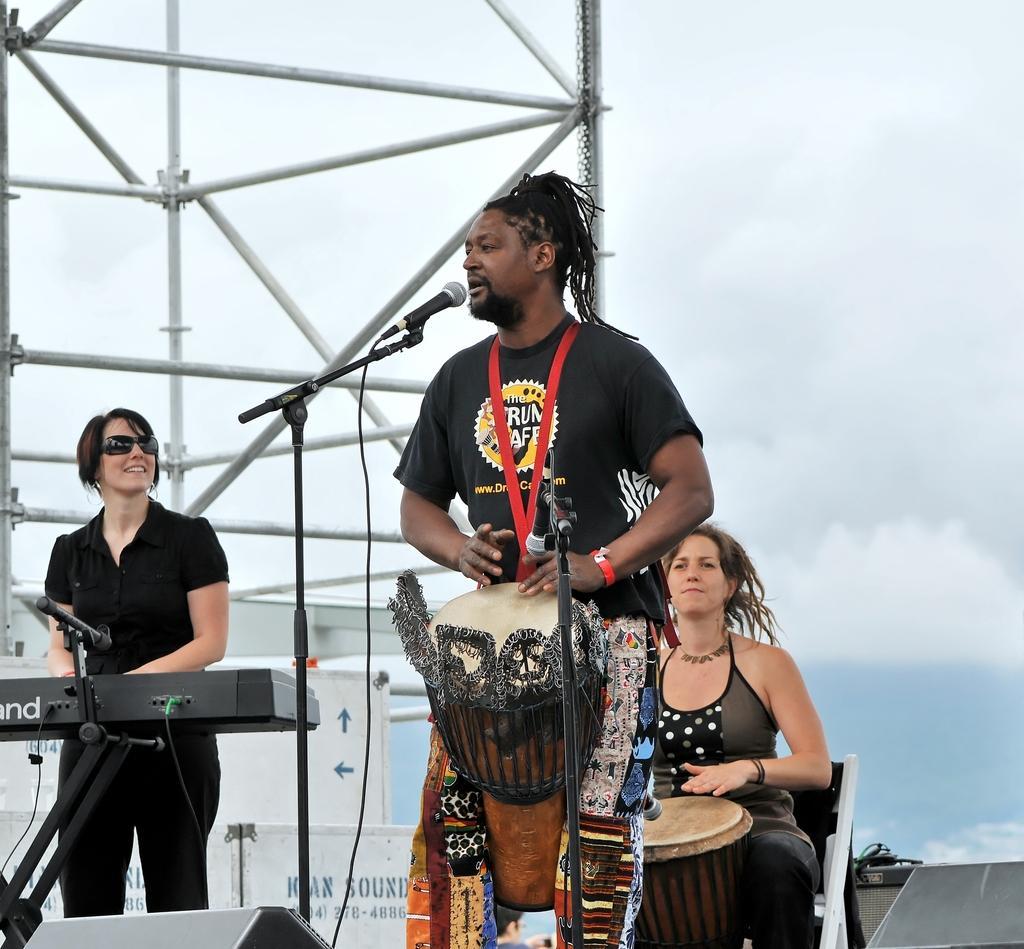Please provide a concise description of this image. In this image I see 3 persons in which 2 of them are women and another is a man. I can also see that 2 of them are standing and this woman is sitting and all of them have their instruments near them. In the background I see rods and the sky. 